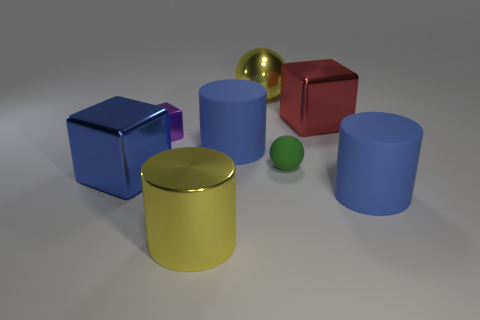Add 1 tiny yellow matte spheres. How many objects exist? 9 Subtract all large rubber cylinders. How many cylinders are left? 1 Subtract 2 cylinders. How many cylinders are left? 1 Subtract all yellow spheres. How many green cylinders are left? 0 Add 3 purple cubes. How many purple cubes exist? 4 Subtract all yellow cylinders. How many cylinders are left? 2 Subtract 1 red cubes. How many objects are left? 7 Subtract all balls. How many objects are left? 6 Subtract all yellow balls. Subtract all green cylinders. How many balls are left? 1 Subtract all large green cylinders. Subtract all big red shiny blocks. How many objects are left? 7 